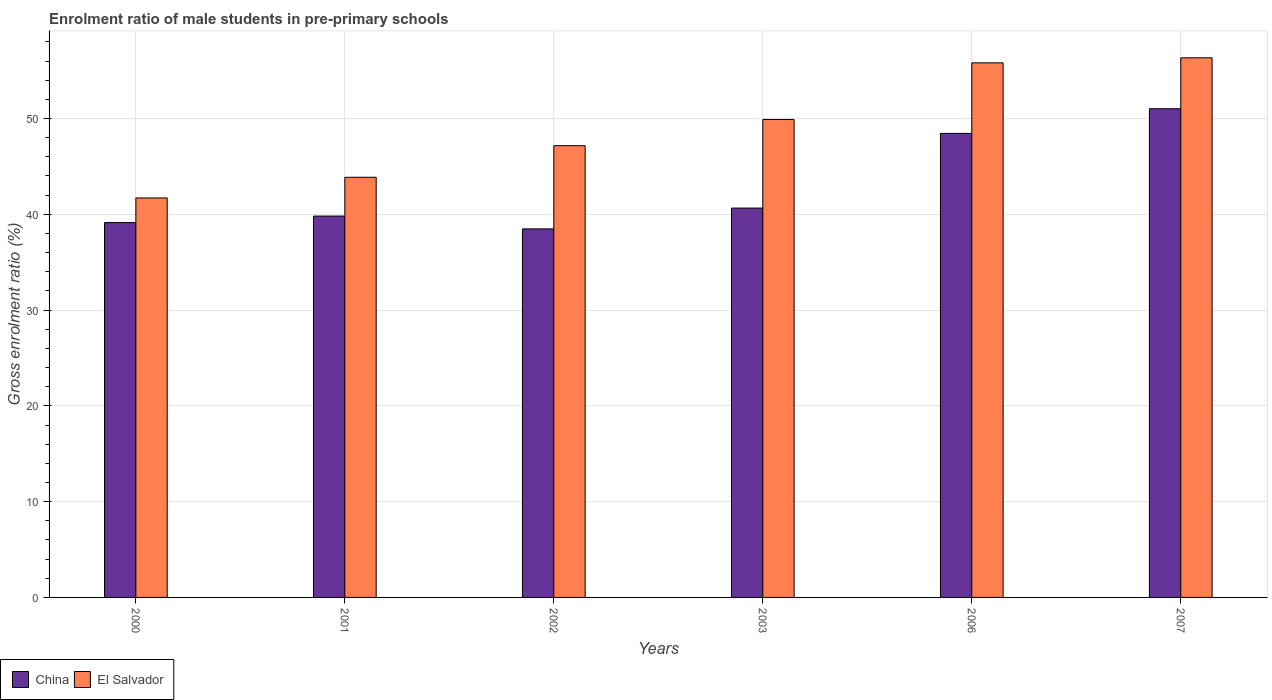Are the number of bars per tick equal to the number of legend labels?
Offer a terse response. Yes. How many bars are there on the 2nd tick from the left?
Offer a very short reply. 2. What is the label of the 4th group of bars from the left?
Make the answer very short. 2003. In how many cases, is the number of bars for a given year not equal to the number of legend labels?
Your response must be concise. 0. What is the enrolment ratio of male students in pre-primary schools in China in 2003?
Your answer should be very brief. 40.65. Across all years, what is the maximum enrolment ratio of male students in pre-primary schools in El Salvador?
Make the answer very short. 56.33. Across all years, what is the minimum enrolment ratio of male students in pre-primary schools in China?
Give a very brief answer. 38.47. What is the total enrolment ratio of male students in pre-primary schools in El Salvador in the graph?
Your answer should be very brief. 294.77. What is the difference between the enrolment ratio of male students in pre-primary schools in China in 2000 and that in 2006?
Provide a short and direct response. -9.31. What is the difference between the enrolment ratio of male students in pre-primary schools in China in 2000 and the enrolment ratio of male students in pre-primary schools in El Salvador in 2006?
Your answer should be very brief. -16.68. What is the average enrolment ratio of male students in pre-primary schools in El Salvador per year?
Your response must be concise. 49.13. In the year 2001, what is the difference between the enrolment ratio of male students in pre-primary schools in El Salvador and enrolment ratio of male students in pre-primary schools in China?
Provide a succinct answer. 4.05. What is the ratio of the enrolment ratio of male students in pre-primary schools in El Salvador in 2001 to that in 2007?
Offer a very short reply. 0.78. What is the difference between the highest and the second highest enrolment ratio of male students in pre-primary schools in China?
Give a very brief answer. 2.58. What is the difference between the highest and the lowest enrolment ratio of male students in pre-primary schools in China?
Make the answer very short. 12.54. In how many years, is the enrolment ratio of male students in pre-primary schools in El Salvador greater than the average enrolment ratio of male students in pre-primary schools in El Salvador taken over all years?
Your answer should be very brief. 3. Is the sum of the enrolment ratio of male students in pre-primary schools in China in 2001 and 2007 greater than the maximum enrolment ratio of male students in pre-primary schools in El Salvador across all years?
Make the answer very short. Yes. What does the 2nd bar from the right in 2006 represents?
Your answer should be compact. China. Are all the bars in the graph horizontal?
Make the answer very short. No. Does the graph contain any zero values?
Ensure brevity in your answer.  No. How many legend labels are there?
Your answer should be very brief. 2. What is the title of the graph?
Your answer should be very brief. Enrolment ratio of male students in pre-primary schools. What is the label or title of the X-axis?
Ensure brevity in your answer.  Years. What is the Gross enrolment ratio (%) in China in 2000?
Give a very brief answer. 39.13. What is the Gross enrolment ratio (%) of El Salvador in 2000?
Your answer should be compact. 41.7. What is the Gross enrolment ratio (%) of China in 2001?
Your response must be concise. 39.81. What is the Gross enrolment ratio (%) in El Salvador in 2001?
Make the answer very short. 43.86. What is the Gross enrolment ratio (%) in China in 2002?
Offer a very short reply. 38.47. What is the Gross enrolment ratio (%) in El Salvador in 2002?
Ensure brevity in your answer.  47.16. What is the Gross enrolment ratio (%) in China in 2003?
Your answer should be compact. 40.65. What is the Gross enrolment ratio (%) in El Salvador in 2003?
Provide a succinct answer. 49.9. What is the Gross enrolment ratio (%) in China in 2006?
Your answer should be very brief. 48.44. What is the Gross enrolment ratio (%) in El Salvador in 2006?
Make the answer very short. 55.81. What is the Gross enrolment ratio (%) of China in 2007?
Offer a terse response. 51.02. What is the Gross enrolment ratio (%) of El Salvador in 2007?
Offer a very short reply. 56.33. Across all years, what is the maximum Gross enrolment ratio (%) in China?
Offer a terse response. 51.02. Across all years, what is the maximum Gross enrolment ratio (%) of El Salvador?
Provide a succinct answer. 56.33. Across all years, what is the minimum Gross enrolment ratio (%) in China?
Your response must be concise. 38.47. Across all years, what is the minimum Gross enrolment ratio (%) of El Salvador?
Your answer should be very brief. 41.7. What is the total Gross enrolment ratio (%) of China in the graph?
Provide a short and direct response. 257.52. What is the total Gross enrolment ratio (%) of El Salvador in the graph?
Offer a terse response. 294.77. What is the difference between the Gross enrolment ratio (%) of China in 2000 and that in 2001?
Offer a very short reply. -0.68. What is the difference between the Gross enrolment ratio (%) in El Salvador in 2000 and that in 2001?
Offer a very short reply. -2.16. What is the difference between the Gross enrolment ratio (%) of China in 2000 and that in 2002?
Give a very brief answer. 0.66. What is the difference between the Gross enrolment ratio (%) of El Salvador in 2000 and that in 2002?
Make the answer very short. -5.45. What is the difference between the Gross enrolment ratio (%) in China in 2000 and that in 2003?
Ensure brevity in your answer.  -1.51. What is the difference between the Gross enrolment ratio (%) in El Salvador in 2000 and that in 2003?
Keep it short and to the point. -8.19. What is the difference between the Gross enrolment ratio (%) in China in 2000 and that in 2006?
Your answer should be compact. -9.31. What is the difference between the Gross enrolment ratio (%) of El Salvador in 2000 and that in 2006?
Ensure brevity in your answer.  -14.1. What is the difference between the Gross enrolment ratio (%) in China in 2000 and that in 2007?
Provide a short and direct response. -11.89. What is the difference between the Gross enrolment ratio (%) of El Salvador in 2000 and that in 2007?
Your answer should be very brief. -14.63. What is the difference between the Gross enrolment ratio (%) of China in 2001 and that in 2002?
Your answer should be compact. 1.34. What is the difference between the Gross enrolment ratio (%) of El Salvador in 2001 and that in 2002?
Provide a succinct answer. -3.3. What is the difference between the Gross enrolment ratio (%) in China in 2001 and that in 2003?
Offer a terse response. -0.83. What is the difference between the Gross enrolment ratio (%) in El Salvador in 2001 and that in 2003?
Provide a short and direct response. -6.03. What is the difference between the Gross enrolment ratio (%) of China in 2001 and that in 2006?
Offer a very short reply. -8.63. What is the difference between the Gross enrolment ratio (%) of El Salvador in 2001 and that in 2006?
Keep it short and to the point. -11.95. What is the difference between the Gross enrolment ratio (%) in China in 2001 and that in 2007?
Your answer should be compact. -11.2. What is the difference between the Gross enrolment ratio (%) in El Salvador in 2001 and that in 2007?
Offer a very short reply. -12.47. What is the difference between the Gross enrolment ratio (%) of China in 2002 and that in 2003?
Offer a terse response. -2.17. What is the difference between the Gross enrolment ratio (%) in El Salvador in 2002 and that in 2003?
Make the answer very short. -2.74. What is the difference between the Gross enrolment ratio (%) in China in 2002 and that in 2006?
Ensure brevity in your answer.  -9.97. What is the difference between the Gross enrolment ratio (%) of El Salvador in 2002 and that in 2006?
Ensure brevity in your answer.  -8.65. What is the difference between the Gross enrolment ratio (%) of China in 2002 and that in 2007?
Your answer should be very brief. -12.54. What is the difference between the Gross enrolment ratio (%) in El Salvador in 2002 and that in 2007?
Offer a terse response. -9.17. What is the difference between the Gross enrolment ratio (%) in China in 2003 and that in 2006?
Give a very brief answer. -7.8. What is the difference between the Gross enrolment ratio (%) in El Salvador in 2003 and that in 2006?
Provide a succinct answer. -5.91. What is the difference between the Gross enrolment ratio (%) of China in 2003 and that in 2007?
Provide a succinct answer. -10.37. What is the difference between the Gross enrolment ratio (%) of El Salvador in 2003 and that in 2007?
Keep it short and to the point. -6.44. What is the difference between the Gross enrolment ratio (%) in China in 2006 and that in 2007?
Give a very brief answer. -2.58. What is the difference between the Gross enrolment ratio (%) of El Salvador in 2006 and that in 2007?
Make the answer very short. -0.53. What is the difference between the Gross enrolment ratio (%) in China in 2000 and the Gross enrolment ratio (%) in El Salvador in 2001?
Give a very brief answer. -4.73. What is the difference between the Gross enrolment ratio (%) of China in 2000 and the Gross enrolment ratio (%) of El Salvador in 2002?
Provide a short and direct response. -8.03. What is the difference between the Gross enrolment ratio (%) in China in 2000 and the Gross enrolment ratio (%) in El Salvador in 2003?
Your answer should be very brief. -10.76. What is the difference between the Gross enrolment ratio (%) of China in 2000 and the Gross enrolment ratio (%) of El Salvador in 2006?
Ensure brevity in your answer.  -16.68. What is the difference between the Gross enrolment ratio (%) of China in 2000 and the Gross enrolment ratio (%) of El Salvador in 2007?
Offer a terse response. -17.2. What is the difference between the Gross enrolment ratio (%) in China in 2001 and the Gross enrolment ratio (%) in El Salvador in 2002?
Give a very brief answer. -7.35. What is the difference between the Gross enrolment ratio (%) in China in 2001 and the Gross enrolment ratio (%) in El Salvador in 2003?
Provide a succinct answer. -10.08. What is the difference between the Gross enrolment ratio (%) in China in 2001 and the Gross enrolment ratio (%) in El Salvador in 2006?
Make the answer very short. -16. What is the difference between the Gross enrolment ratio (%) of China in 2001 and the Gross enrolment ratio (%) of El Salvador in 2007?
Offer a very short reply. -16.52. What is the difference between the Gross enrolment ratio (%) in China in 2002 and the Gross enrolment ratio (%) in El Salvador in 2003?
Give a very brief answer. -11.42. What is the difference between the Gross enrolment ratio (%) of China in 2002 and the Gross enrolment ratio (%) of El Salvador in 2006?
Provide a short and direct response. -17.33. What is the difference between the Gross enrolment ratio (%) in China in 2002 and the Gross enrolment ratio (%) in El Salvador in 2007?
Ensure brevity in your answer.  -17.86. What is the difference between the Gross enrolment ratio (%) in China in 2003 and the Gross enrolment ratio (%) in El Salvador in 2006?
Your answer should be compact. -15.16. What is the difference between the Gross enrolment ratio (%) of China in 2003 and the Gross enrolment ratio (%) of El Salvador in 2007?
Give a very brief answer. -15.69. What is the difference between the Gross enrolment ratio (%) of China in 2006 and the Gross enrolment ratio (%) of El Salvador in 2007?
Your answer should be compact. -7.89. What is the average Gross enrolment ratio (%) in China per year?
Your response must be concise. 42.92. What is the average Gross enrolment ratio (%) of El Salvador per year?
Make the answer very short. 49.13. In the year 2000, what is the difference between the Gross enrolment ratio (%) in China and Gross enrolment ratio (%) in El Salvador?
Give a very brief answer. -2.57. In the year 2001, what is the difference between the Gross enrolment ratio (%) in China and Gross enrolment ratio (%) in El Salvador?
Give a very brief answer. -4.05. In the year 2002, what is the difference between the Gross enrolment ratio (%) in China and Gross enrolment ratio (%) in El Salvador?
Offer a very short reply. -8.68. In the year 2003, what is the difference between the Gross enrolment ratio (%) of China and Gross enrolment ratio (%) of El Salvador?
Your response must be concise. -9.25. In the year 2006, what is the difference between the Gross enrolment ratio (%) in China and Gross enrolment ratio (%) in El Salvador?
Make the answer very short. -7.37. In the year 2007, what is the difference between the Gross enrolment ratio (%) of China and Gross enrolment ratio (%) of El Salvador?
Keep it short and to the point. -5.32. What is the ratio of the Gross enrolment ratio (%) in China in 2000 to that in 2001?
Keep it short and to the point. 0.98. What is the ratio of the Gross enrolment ratio (%) of El Salvador in 2000 to that in 2001?
Your response must be concise. 0.95. What is the ratio of the Gross enrolment ratio (%) of China in 2000 to that in 2002?
Provide a succinct answer. 1.02. What is the ratio of the Gross enrolment ratio (%) of El Salvador in 2000 to that in 2002?
Provide a succinct answer. 0.88. What is the ratio of the Gross enrolment ratio (%) of China in 2000 to that in 2003?
Your answer should be very brief. 0.96. What is the ratio of the Gross enrolment ratio (%) in El Salvador in 2000 to that in 2003?
Keep it short and to the point. 0.84. What is the ratio of the Gross enrolment ratio (%) of China in 2000 to that in 2006?
Provide a short and direct response. 0.81. What is the ratio of the Gross enrolment ratio (%) of El Salvador in 2000 to that in 2006?
Your response must be concise. 0.75. What is the ratio of the Gross enrolment ratio (%) in China in 2000 to that in 2007?
Keep it short and to the point. 0.77. What is the ratio of the Gross enrolment ratio (%) of El Salvador in 2000 to that in 2007?
Give a very brief answer. 0.74. What is the ratio of the Gross enrolment ratio (%) in China in 2001 to that in 2002?
Your answer should be compact. 1.03. What is the ratio of the Gross enrolment ratio (%) in El Salvador in 2001 to that in 2002?
Your answer should be compact. 0.93. What is the ratio of the Gross enrolment ratio (%) in China in 2001 to that in 2003?
Your response must be concise. 0.98. What is the ratio of the Gross enrolment ratio (%) of El Salvador in 2001 to that in 2003?
Your answer should be compact. 0.88. What is the ratio of the Gross enrolment ratio (%) of China in 2001 to that in 2006?
Provide a succinct answer. 0.82. What is the ratio of the Gross enrolment ratio (%) in El Salvador in 2001 to that in 2006?
Provide a short and direct response. 0.79. What is the ratio of the Gross enrolment ratio (%) in China in 2001 to that in 2007?
Your response must be concise. 0.78. What is the ratio of the Gross enrolment ratio (%) in El Salvador in 2001 to that in 2007?
Provide a succinct answer. 0.78. What is the ratio of the Gross enrolment ratio (%) of China in 2002 to that in 2003?
Provide a short and direct response. 0.95. What is the ratio of the Gross enrolment ratio (%) of El Salvador in 2002 to that in 2003?
Keep it short and to the point. 0.95. What is the ratio of the Gross enrolment ratio (%) of China in 2002 to that in 2006?
Ensure brevity in your answer.  0.79. What is the ratio of the Gross enrolment ratio (%) of El Salvador in 2002 to that in 2006?
Make the answer very short. 0.84. What is the ratio of the Gross enrolment ratio (%) in China in 2002 to that in 2007?
Provide a short and direct response. 0.75. What is the ratio of the Gross enrolment ratio (%) of El Salvador in 2002 to that in 2007?
Offer a very short reply. 0.84. What is the ratio of the Gross enrolment ratio (%) of China in 2003 to that in 2006?
Make the answer very short. 0.84. What is the ratio of the Gross enrolment ratio (%) of El Salvador in 2003 to that in 2006?
Give a very brief answer. 0.89. What is the ratio of the Gross enrolment ratio (%) of China in 2003 to that in 2007?
Your answer should be very brief. 0.8. What is the ratio of the Gross enrolment ratio (%) in El Salvador in 2003 to that in 2007?
Provide a succinct answer. 0.89. What is the ratio of the Gross enrolment ratio (%) of China in 2006 to that in 2007?
Provide a short and direct response. 0.95. What is the ratio of the Gross enrolment ratio (%) of El Salvador in 2006 to that in 2007?
Keep it short and to the point. 0.99. What is the difference between the highest and the second highest Gross enrolment ratio (%) in China?
Provide a succinct answer. 2.58. What is the difference between the highest and the second highest Gross enrolment ratio (%) of El Salvador?
Your answer should be very brief. 0.53. What is the difference between the highest and the lowest Gross enrolment ratio (%) in China?
Your answer should be compact. 12.54. What is the difference between the highest and the lowest Gross enrolment ratio (%) in El Salvador?
Keep it short and to the point. 14.63. 